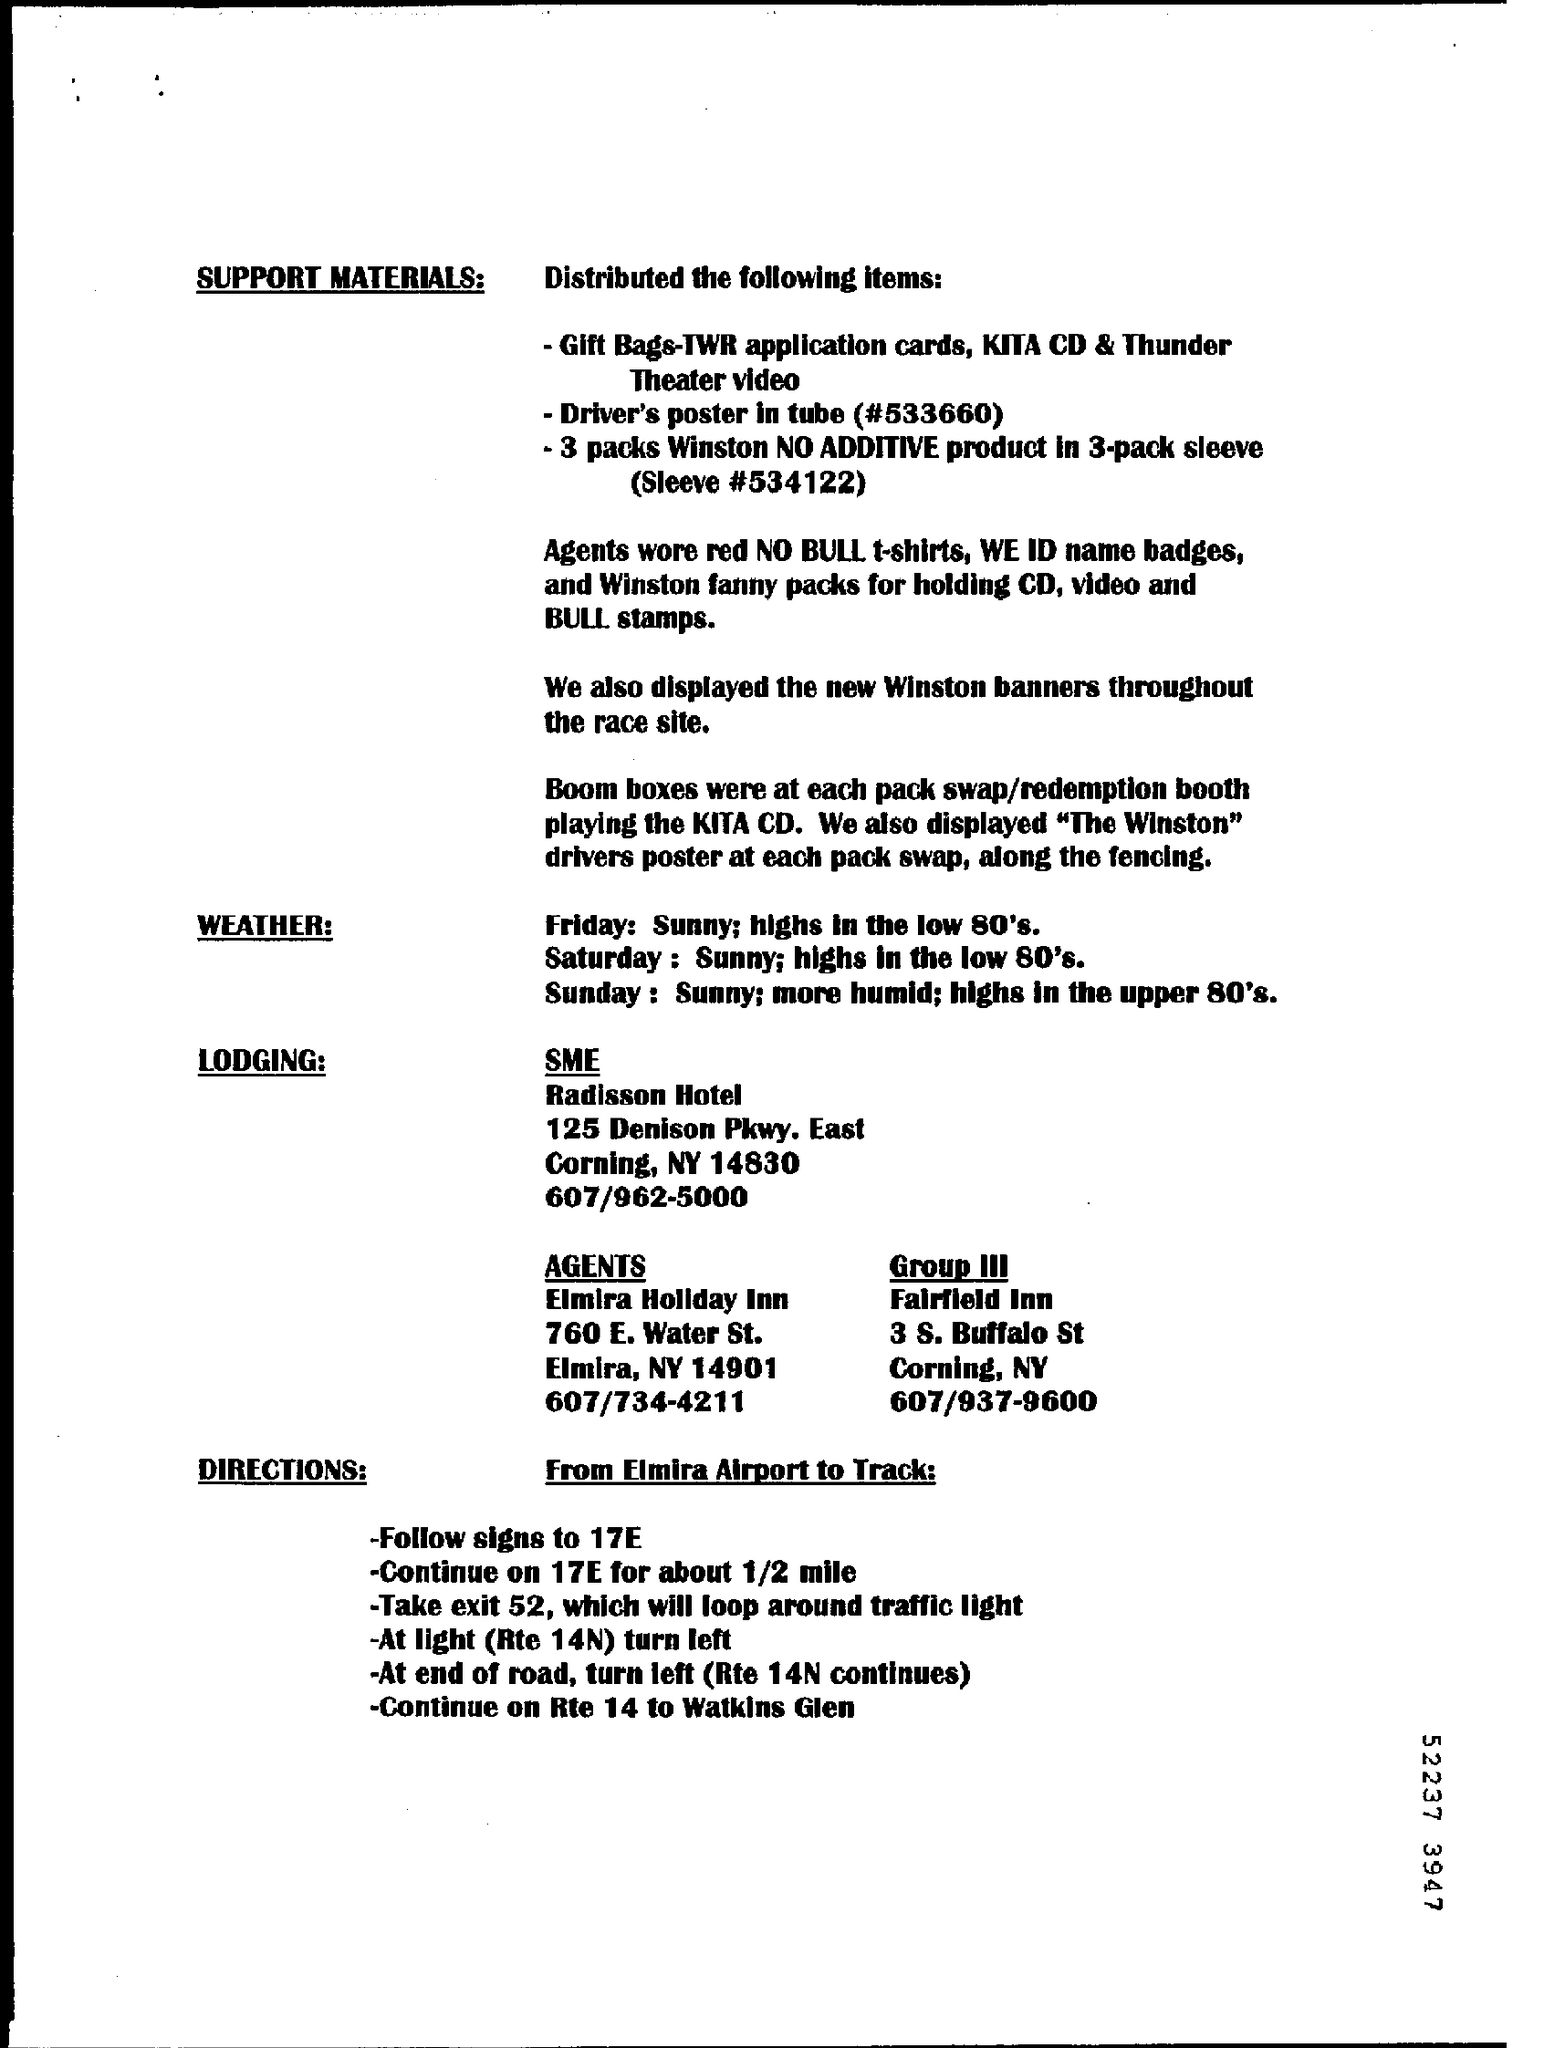What kind of new banners were displayed through the Race site?
Your response must be concise. Winston. 